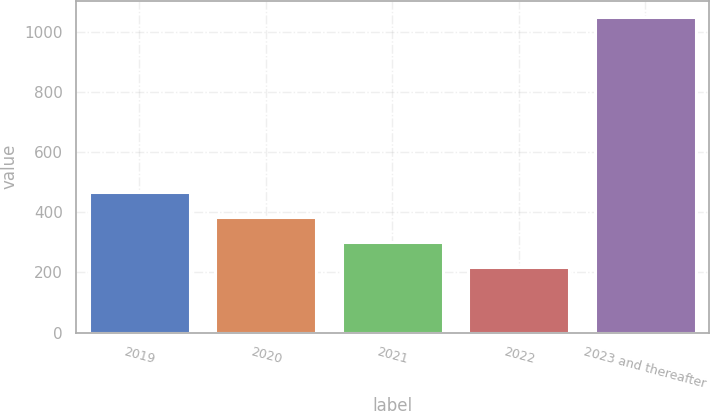<chart> <loc_0><loc_0><loc_500><loc_500><bar_chart><fcel>2019<fcel>2020<fcel>2021<fcel>2022<fcel>2023 and thereafter<nl><fcel>467.2<fcel>383.8<fcel>300.4<fcel>217<fcel>1051<nl></chart> 